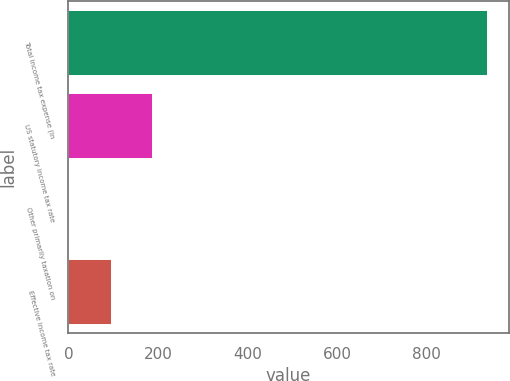Convert chart. <chart><loc_0><loc_0><loc_500><loc_500><bar_chart><fcel>Total income tax expense (In<fcel>US statutory income tax rate<fcel>Other primarily taxation on<fcel>Effective income tax rate<nl><fcel>936<fcel>189.6<fcel>3<fcel>96.3<nl></chart> 